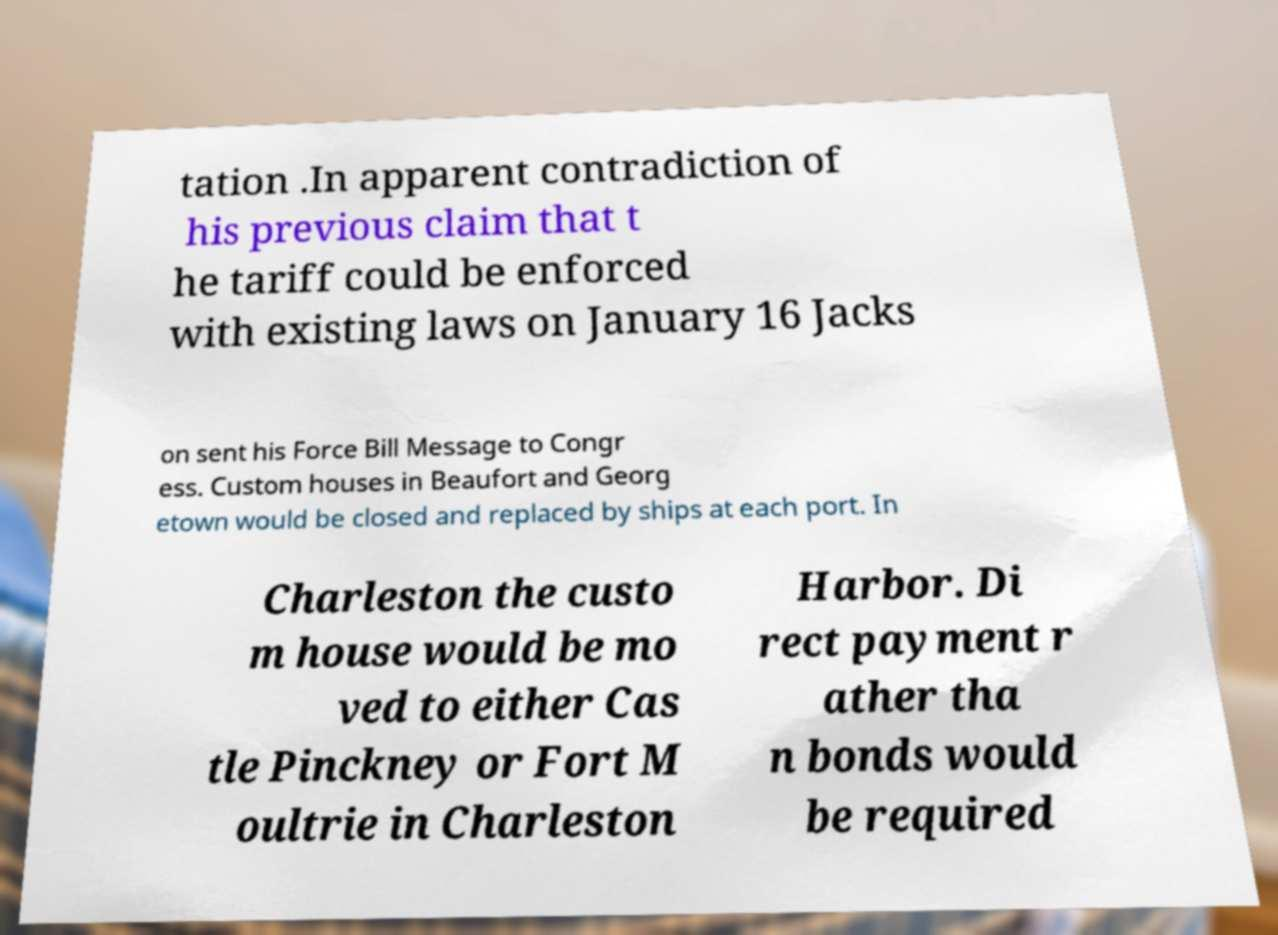Please identify and transcribe the text found in this image. tation .In apparent contradiction of his previous claim that t he tariff could be enforced with existing laws on January 16 Jacks on sent his Force Bill Message to Congr ess. Custom houses in Beaufort and Georg etown would be closed and replaced by ships at each port. In Charleston the custo m house would be mo ved to either Cas tle Pinckney or Fort M oultrie in Charleston Harbor. Di rect payment r ather tha n bonds would be required 